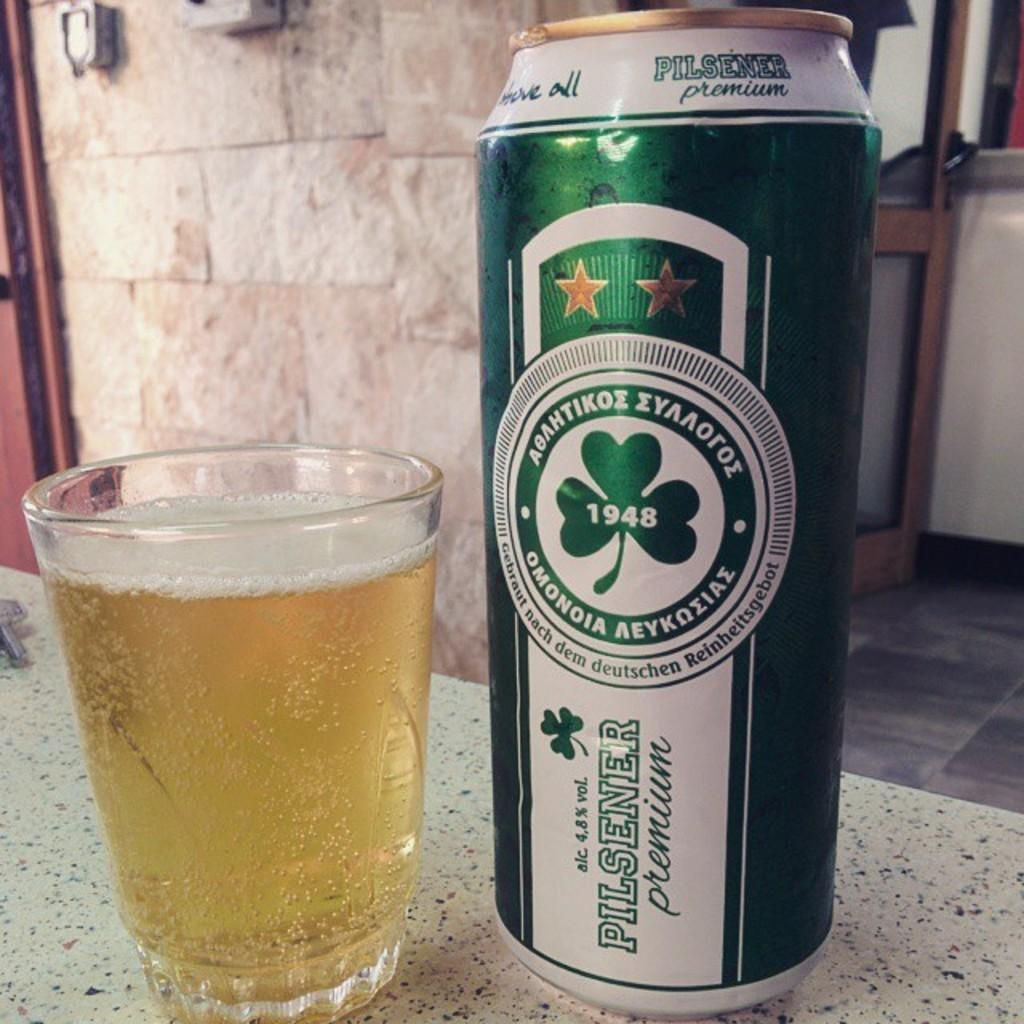Provide a one-sentence caption for the provided image. A can of Pilsner premium ale next to a glass of what is presumably the same. 